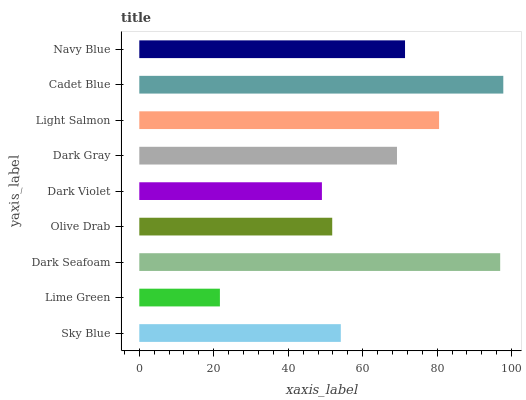Is Lime Green the minimum?
Answer yes or no. Yes. Is Cadet Blue the maximum?
Answer yes or no. Yes. Is Dark Seafoam the minimum?
Answer yes or no. No. Is Dark Seafoam the maximum?
Answer yes or no. No. Is Dark Seafoam greater than Lime Green?
Answer yes or no. Yes. Is Lime Green less than Dark Seafoam?
Answer yes or no. Yes. Is Lime Green greater than Dark Seafoam?
Answer yes or no. No. Is Dark Seafoam less than Lime Green?
Answer yes or no. No. Is Dark Gray the high median?
Answer yes or no. Yes. Is Dark Gray the low median?
Answer yes or no. Yes. Is Light Salmon the high median?
Answer yes or no. No. Is Navy Blue the low median?
Answer yes or no. No. 